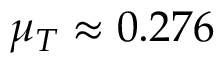Convert formula to latex. <formula><loc_0><loc_0><loc_500><loc_500>\mu _ { T } \approx 0 . 2 7 6</formula> 